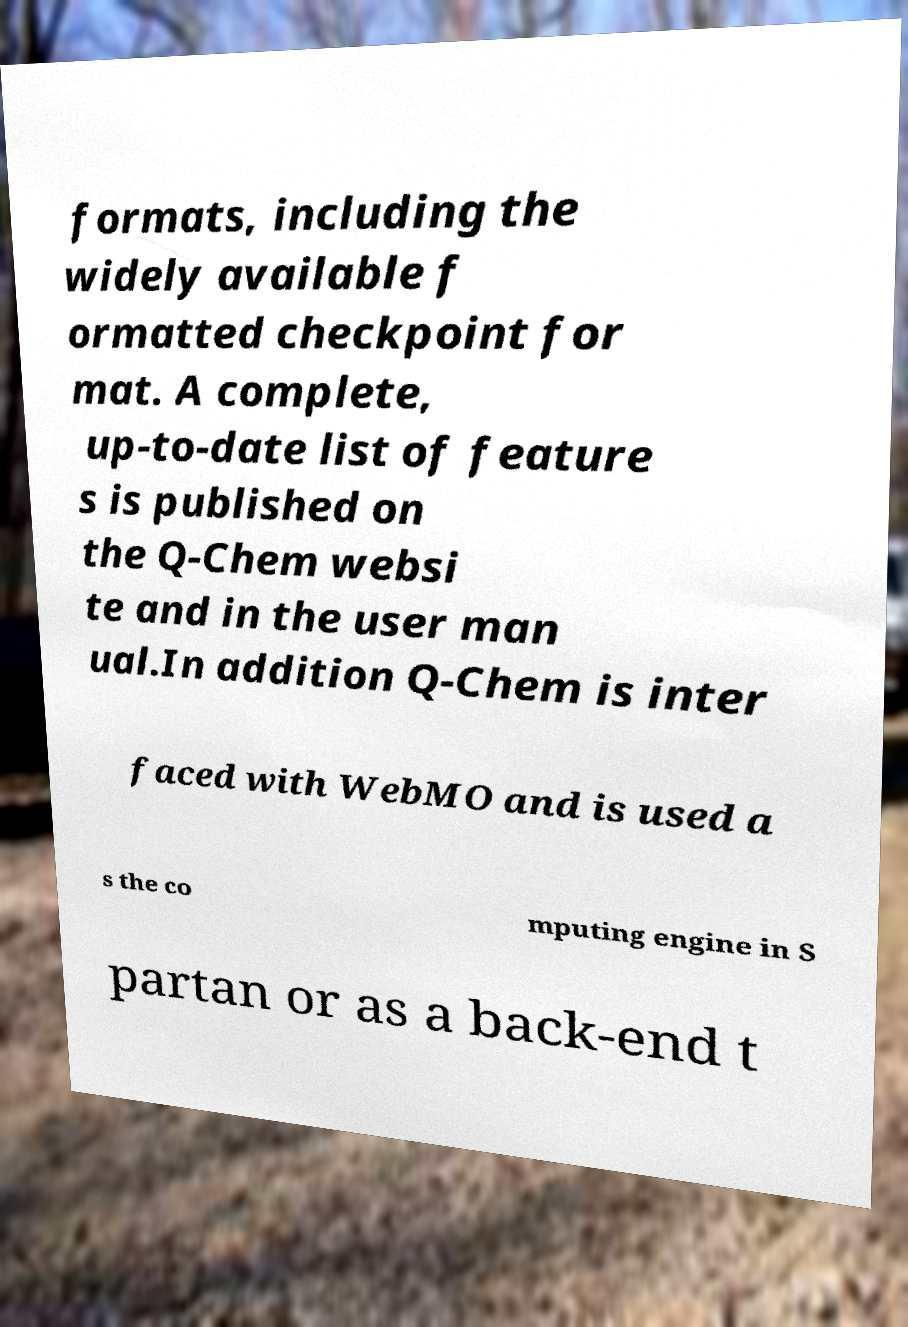For documentation purposes, I need the text within this image transcribed. Could you provide that? formats, including the widely available f ormatted checkpoint for mat. A complete, up-to-date list of feature s is published on the Q-Chem websi te and in the user man ual.In addition Q-Chem is inter faced with WebMO and is used a s the co mputing engine in S partan or as a back-end t 